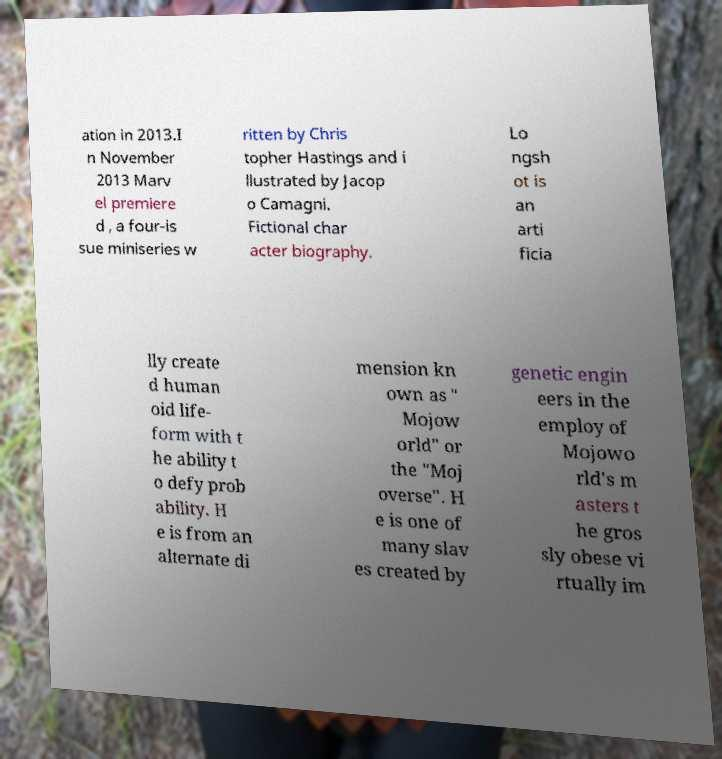Could you assist in decoding the text presented in this image and type it out clearly? ation in 2013.I n November 2013 Marv el premiere d , a four-is sue miniseries w ritten by Chris topher Hastings and i llustrated by Jacop o Camagni. Fictional char acter biography. Lo ngsh ot is an arti ficia lly create d human oid life- form with t he ability t o defy prob ability. H e is from an alternate di mension kn own as " Mojow orld" or the "Moj overse". H e is one of many slav es created by genetic engin eers in the employ of Mojowo rld's m asters t he gros sly obese vi rtually im 